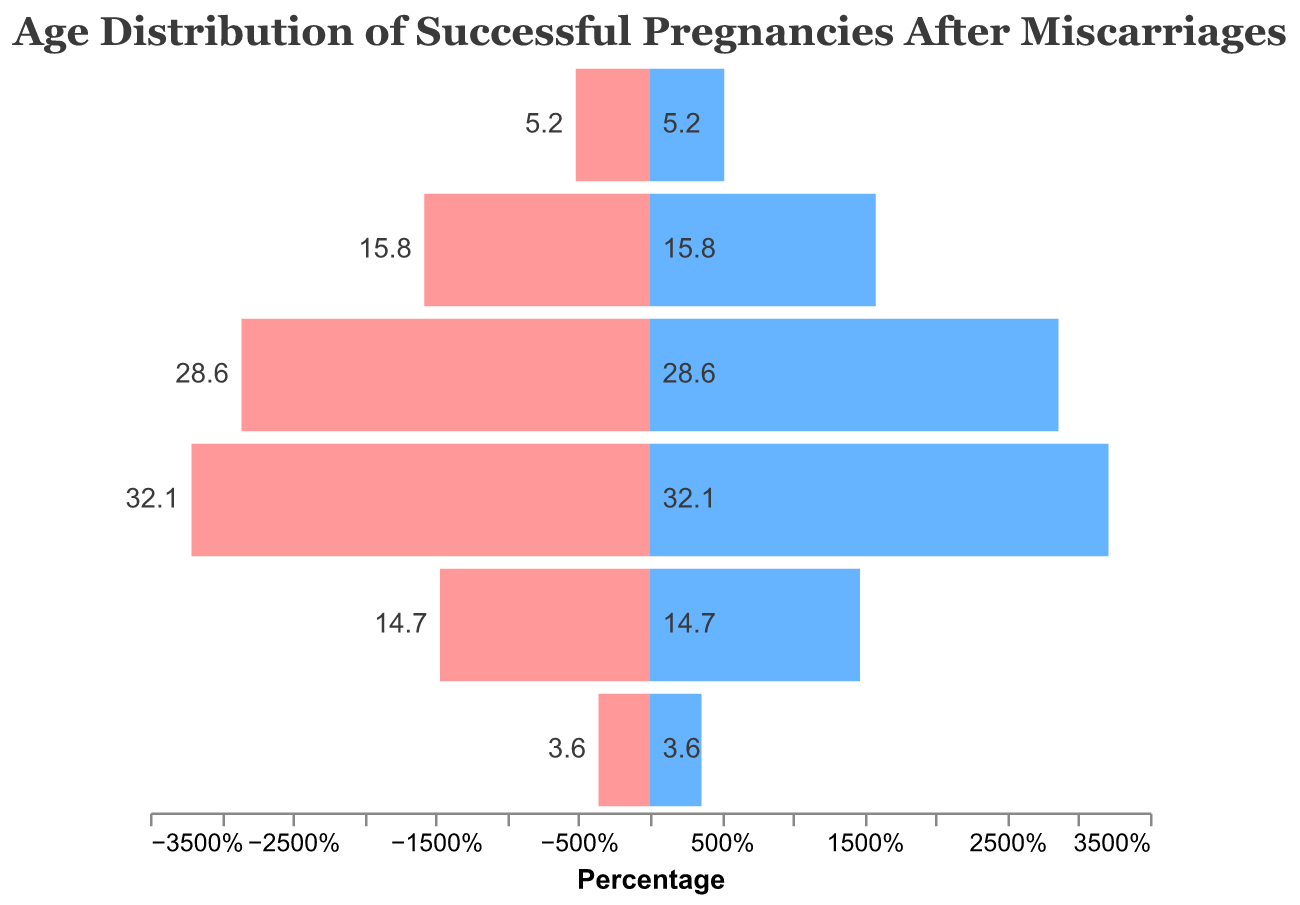Which age group has the highest percentage of successful pregnancies after miscarriages? By looking at the figure, the age group with the highest percentage bar will be the one that stands out the most and is visually the longest.
Answer: 35-39 What is the percentage of successful pregnancies for women aged 30-34? Locate the bar corresponding to the age group 30-34 and read the percentage value either from the text annotation or the bar's length.
Answer: 28.6% Which age group has the lowest percentage of successful pregnancies after miscarriages? By identifying the shortest bar, which reflects the smallest percentage, we can determine the lowest percentage age group.
Answer: 45+ How much higher is the percentage of successful pregnancies for women aged 35-39 compared to those aged 25-29? Locate and compare the percentage values for the two age groups: 35-39 and 25-29, and calculate the difference as 32.1% - 15.8%.
Answer: 16.3% What is the combined percentage of successful pregnancies for the age groups 18-24 and 45+? Add the two percentages together: 5.2% + 3.6%.
Answer: 8.8% How does the percentage of successful pregnancies for women aged 25-29 compare to those aged 40-44? Compare the percentage values of the two age groups: 25-29 and 40-44, and determine which is larger or if they are equal.
Answer: 25-29 is higher What is the average percentage of successful pregnancies for women aged 25-34? Calculate the average of the percentages for the age groups 25-29 and 30-34: (15.8% + 28.6%) / 2.
Answer: 22.2% What is the range of percentages for the age groups shown in the figure? Identify the highest and lowest percentage values and subtract the lowest from the highest: 32.1% - 3.6%.
Answer: 28.5% What percentage of successful pregnancies occur for women aged 35 and older? Add the percentages for the age groups 35-39, 40-44, and 45+: 32.1% + 14.7% + 3.6%.
Answer: 50.4% Which two age groups have the closest percentages of successful pregnancies? Compare the percentage values and find the two age groups with the smallest difference.
Answer: 25-29 and 40-44 